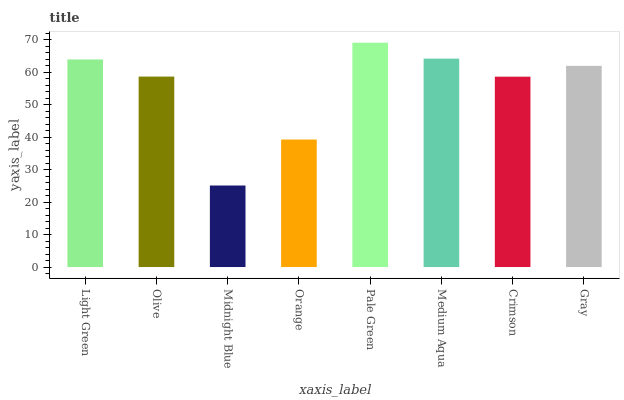Is Olive the minimum?
Answer yes or no. No. Is Olive the maximum?
Answer yes or no. No. Is Light Green greater than Olive?
Answer yes or no. Yes. Is Olive less than Light Green?
Answer yes or no. Yes. Is Olive greater than Light Green?
Answer yes or no. No. Is Light Green less than Olive?
Answer yes or no. No. Is Gray the high median?
Answer yes or no. Yes. Is Olive the low median?
Answer yes or no. Yes. Is Midnight Blue the high median?
Answer yes or no. No. Is Pale Green the low median?
Answer yes or no. No. 